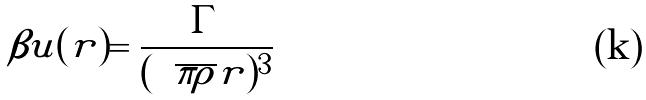Convert formula to latex. <formula><loc_0><loc_0><loc_500><loc_500>\beta u ( r ) = \frac { \Gamma } { ( \sqrt { \pi \rho } r ) ^ { 3 } }</formula> 